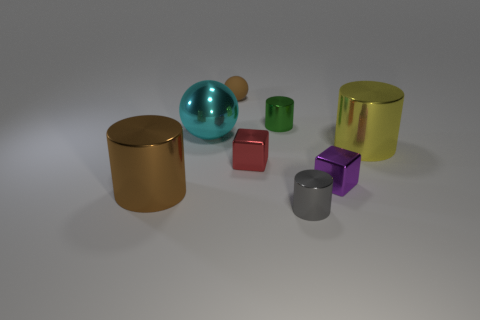Add 1 blocks. How many objects exist? 9 Subtract all gray shiny cylinders. How many cylinders are left? 3 Subtract all purple cylinders. How many green blocks are left? 0 Subtract all tiny red things. Subtract all matte balls. How many objects are left? 6 Add 7 large yellow objects. How many large yellow objects are left? 8 Add 2 big brown metal cylinders. How many big brown metal cylinders exist? 3 Subtract all green cylinders. How many cylinders are left? 3 Subtract 1 yellow cylinders. How many objects are left? 7 Subtract all blocks. How many objects are left? 6 Subtract 2 cubes. How many cubes are left? 0 